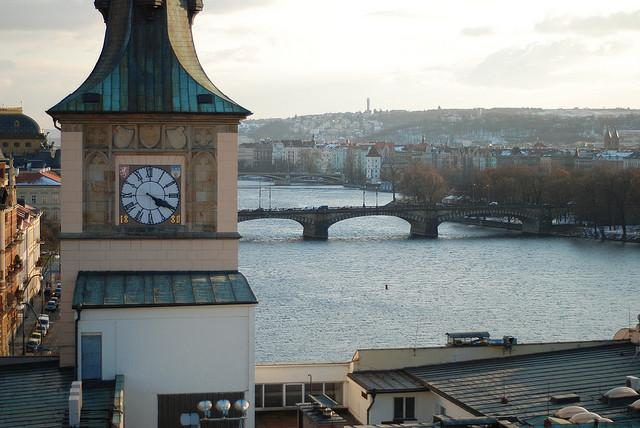What do the numbers on either side of the clock represent? time 